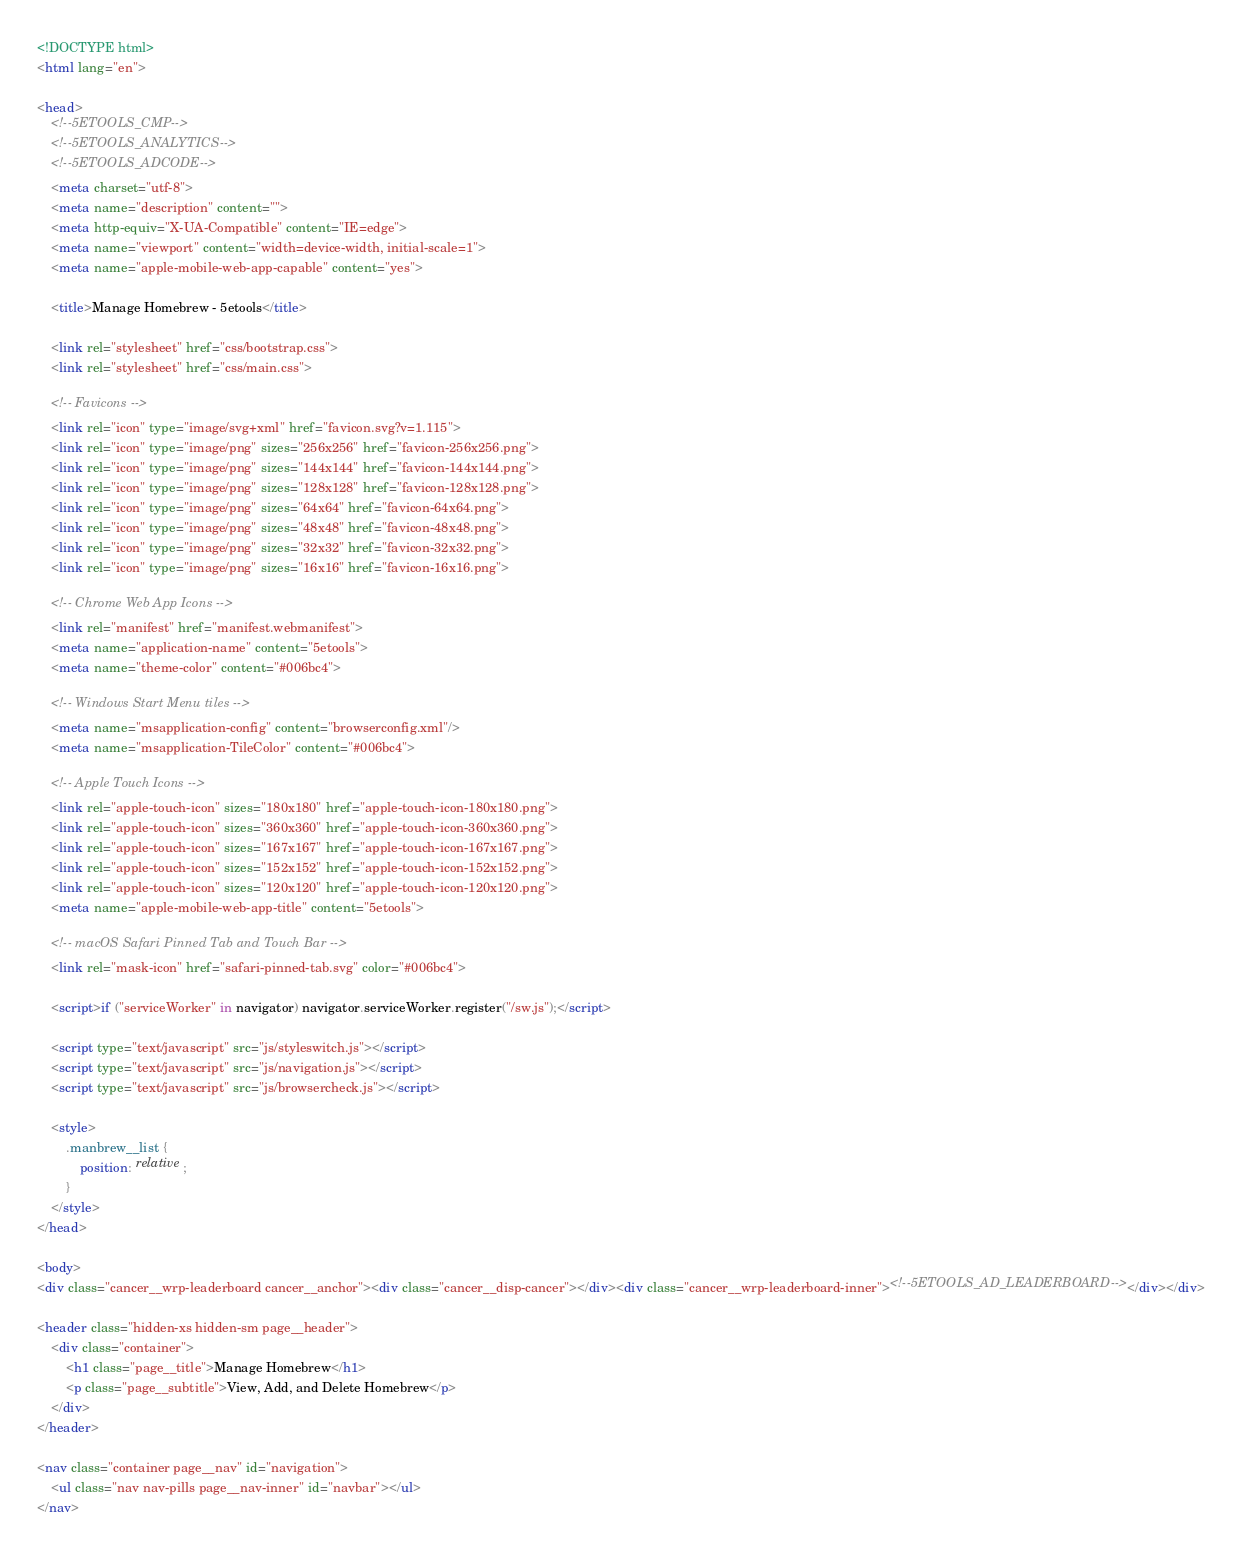Convert code to text. <code><loc_0><loc_0><loc_500><loc_500><_HTML_><!DOCTYPE html>
<html lang="en">

<head>
	<!--5ETOOLS_CMP-->
	<!--5ETOOLS_ANALYTICS-->
	<!--5ETOOLS_ADCODE-->
	<meta charset="utf-8">
	<meta name="description" content="">
	<meta http-equiv="X-UA-Compatible" content="IE=edge">
	<meta name="viewport" content="width=device-width, initial-scale=1">
	<meta name="apple-mobile-web-app-capable" content="yes">

	<title>Manage Homebrew - 5etools</title>

	<link rel="stylesheet" href="css/bootstrap.css">
	<link rel="stylesheet" href="css/main.css">

	<!-- Favicons -->
	<link rel="icon" type="image/svg+xml" href="favicon.svg?v=1.115">
	<link rel="icon" type="image/png" sizes="256x256" href="favicon-256x256.png">
	<link rel="icon" type="image/png" sizes="144x144" href="favicon-144x144.png">
	<link rel="icon" type="image/png" sizes="128x128" href="favicon-128x128.png">
	<link rel="icon" type="image/png" sizes="64x64" href="favicon-64x64.png">
	<link rel="icon" type="image/png" sizes="48x48" href="favicon-48x48.png">
	<link rel="icon" type="image/png" sizes="32x32" href="favicon-32x32.png">
	<link rel="icon" type="image/png" sizes="16x16" href="favicon-16x16.png">

	<!-- Chrome Web App Icons -->
	<link rel="manifest" href="manifest.webmanifest">
	<meta name="application-name" content="5etools">
	<meta name="theme-color" content="#006bc4">

	<!-- Windows Start Menu tiles -->
	<meta name="msapplication-config" content="browserconfig.xml"/>
	<meta name="msapplication-TileColor" content="#006bc4">

	<!-- Apple Touch Icons -->
	<link rel="apple-touch-icon" sizes="180x180" href="apple-touch-icon-180x180.png">
	<link rel="apple-touch-icon" sizes="360x360" href="apple-touch-icon-360x360.png">
	<link rel="apple-touch-icon" sizes="167x167" href="apple-touch-icon-167x167.png">
	<link rel="apple-touch-icon" sizes="152x152" href="apple-touch-icon-152x152.png">
	<link rel="apple-touch-icon" sizes="120x120" href="apple-touch-icon-120x120.png">
	<meta name="apple-mobile-web-app-title" content="5etools">

	<!-- macOS Safari Pinned Tab and Touch Bar -->
	<link rel="mask-icon" href="safari-pinned-tab.svg" color="#006bc4">

	<script>if ("serviceWorker" in navigator) navigator.serviceWorker.register("/sw.js");</script>

	<script type="text/javascript" src="js/styleswitch.js"></script>
	<script type="text/javascript" src="js/navigation.js"></script>
	<script type="text/javascript" src="js/browsercheck.js"></script>

	<style>
		.manbrew__list {
			position: relative;
		}
	</style>
</head>

<body>
<div class="cancer__wrp-leaderboard cancer__anchor"><div class="cancer__disp-cancer"></div><div class="cancer__wrp-leaderboard-inner"><!--5ETOOLS_AD_LEADERBOARD--></div></div>

<header class="hidden-xs hidden-sm page__header">
	<div class="container">
		<h1 class="page__title">Manage Homebrew</h1>
		<p class="page__subtitle">View, Add, and Delete Homebrew</p>
	</div>
</header>

<nav class="container page__nav" id="navigation">
	<ul class="nav nav-pills page__nav-inner" id="navbar"></ul>
</nav>
</code> 